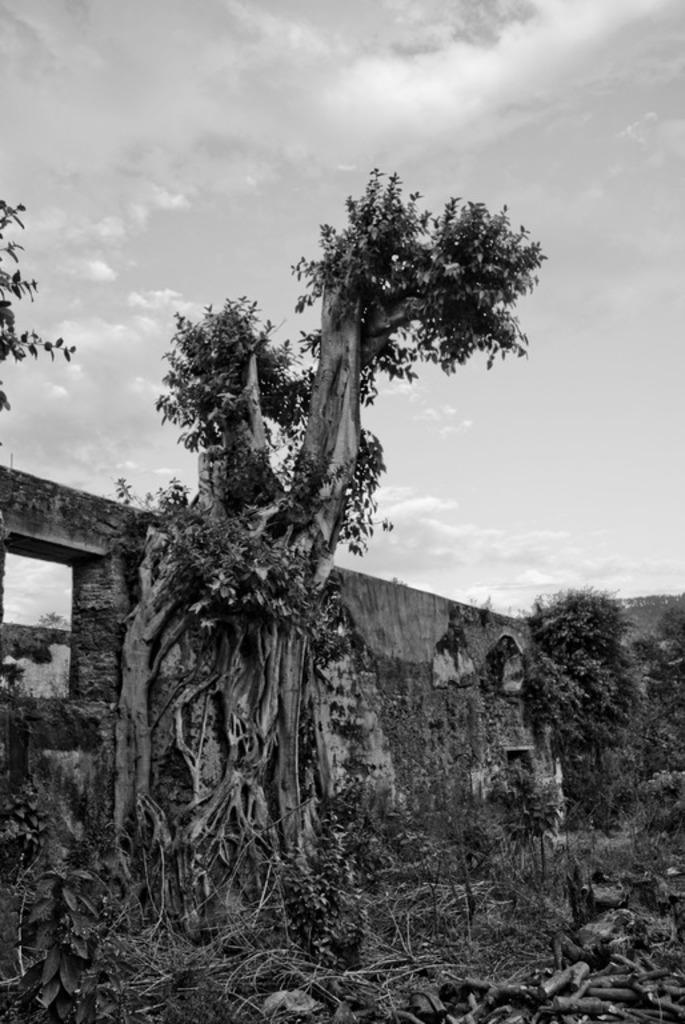What type of vegetation can be seen in the image? There are trees, plants, and grass visible in the image. What other objects can be seen in the image? There are trunks and a wall in the image. What is visible in the background of the image? The sky is visible in the image. How is the image presented? The image is in black and white mode. What type of leather material can be seen on the wall in the image? There is no leather material present on the wall in the image; it is a black and white image with no color or texture details. 